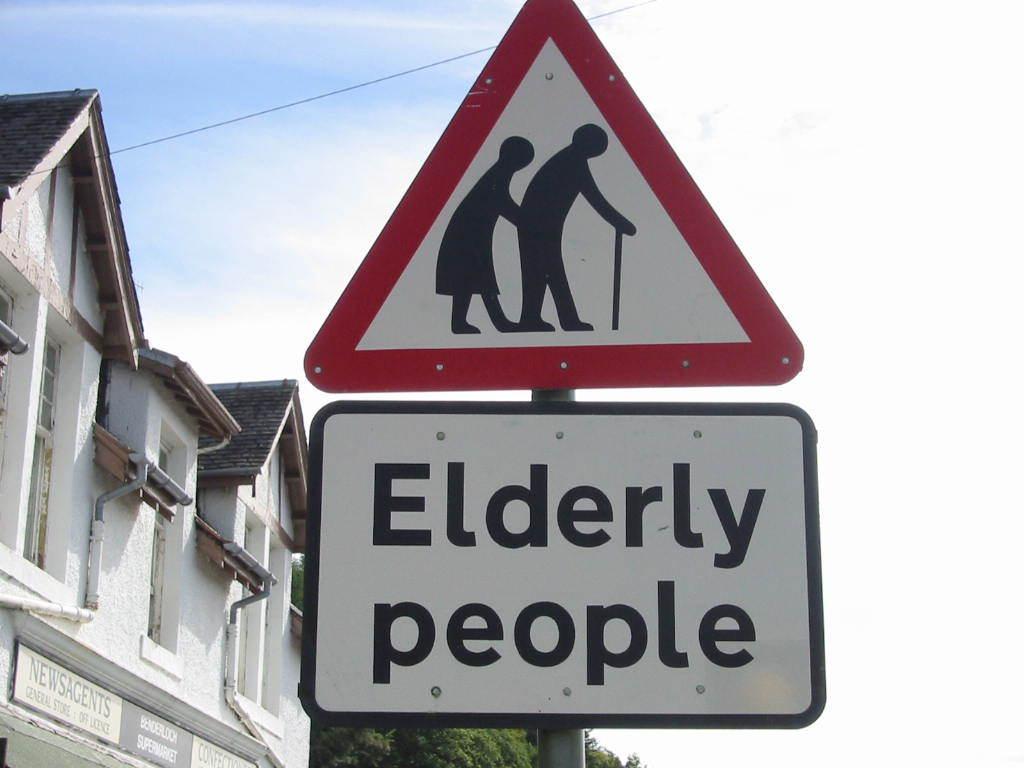What kind of people are stated on the sign?
Provide a short and direct response. Elderly people. How many figures of people are on the sign?
Make the answer very short. 2. 